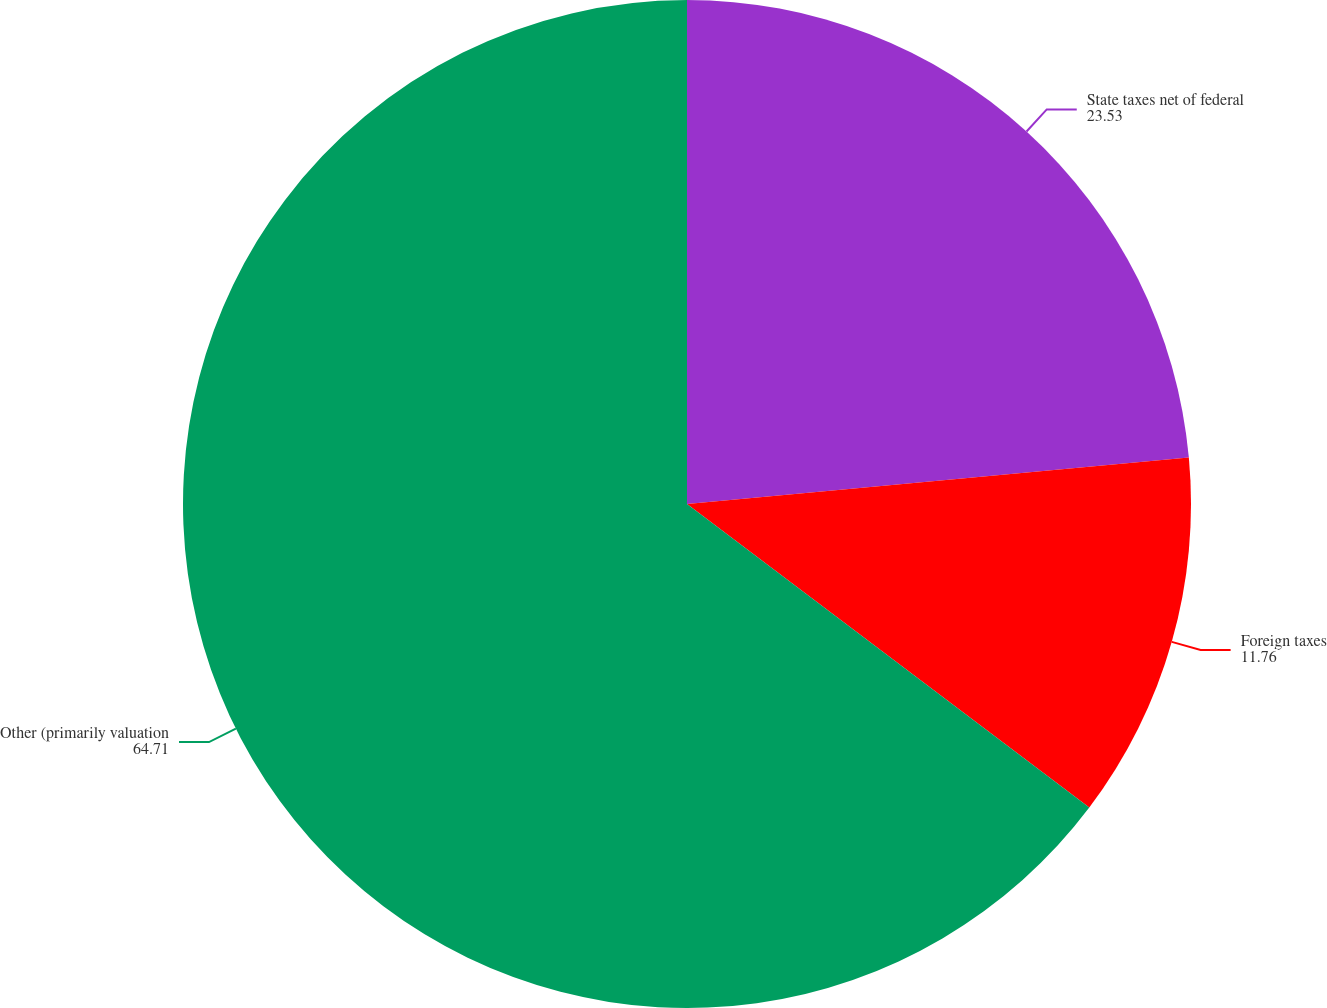Convert chart. <chart><loc_0><loc_0><loc_500><loc_500><pie_chart><fcel>State taxes net of federal<fcel>Foreign taxes<fcel>Other (primarily valuation<nl><fcel>23.53%<fcel>11.76%<fcel>64.71%<nl></chart> 